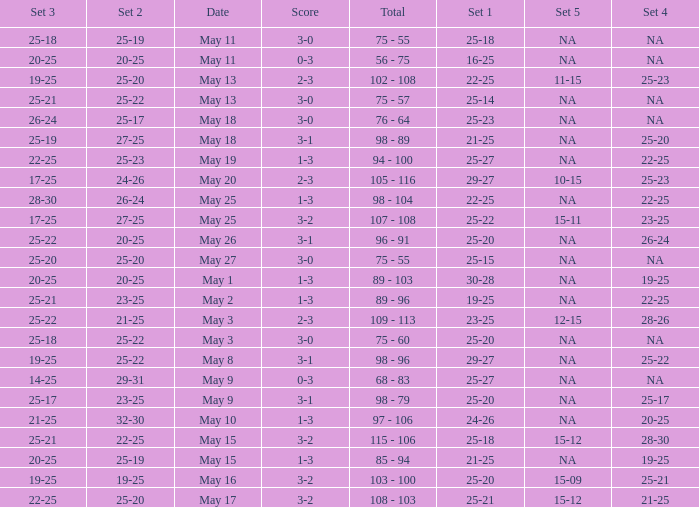Help me parse the entirety of this table. {'header': ['Set 3', 'Set 2', 'Date', 'Score', 'Total', 'Set 1', 'Set 5', 'Set 4'], 'rows': [['25-18', '25-19', 'May 11', '3-0', '75 - 55', '25-18', 'NA', 'NA'], ['20-25', '20-25', 'May 11', '0-3', '56 - 75', '16-25', 'NA', 'NA'], ['19-25', '25-20', 'May 13', '2-3', '102 - 108', '22-25', '11-15', '25-23'], ['25-21', '25-22', 'May 13', '3-0', '75 - 57', '25-14', 'NA', 'NA'], ['26-24', '25-17', 'May 18', '3-0', '76 - 64', '25-23', 'NA', 'NA'], ['25-19', '27-25', 'May 18', '3-1', '98 - 89', '21-25', 'NA', '25-20'], ['22-25', '25-23', 'May 19', '1-3', '94 - 100', '25-27', 'NA', '22-25'], ['17-25', '24-26', 'May 20', '2-3', '105 - 116', '29-27', '10-15', '25-23'], ['28-30', '26-24', 'May 25', '1-3', '98 - 104', '22-25', 'NA', '22-25'], ['17-25', '27-25', 'May 25', '3-2', '107 - 108', '25-22', '15-11', '23-25'], ['25-22', '20-25', 'May 26', '3-1', '96 - 91', '25-20', 'NA', '26-24'], ['25-20', '25-20', 'May 27', '3-0', '75 - 55', '25-15', 'NA', 'NA'], ['20-25', '20-25', 'May 1', '1-3', '89 - 103', '30-28', 'NA', '19-25'], ['25-21', '23-25', 'May 2', '1-3', '89 - 96', '19-25', 'NA', '22-25'], ['25-22', '21-25', 'May 3', '2-3', '109 - 113', '23-25', '12-15', '28-26'], ['25-18', '25-22', 'May 3', '3-0', '75 - 60', '25-20', 'NA', 'NA'], ['19-25', '25-22', 'May 8', '3-1', '98 - 96', '29-27', 'NA', '25-22'], ['14-25', '29-31', 'May 9', '0-3', '68 - 83', '25-27', 'NA', 'NA'], ['25-17', '23-25', 'May 9', '3-1', '98 - 79', '25-20', 'NA', '25-17'], ['21-25', '32-30', 'May 10', '1-3', '97 - 106', '24-26', 'NA', '20-25'], ['25-21', '22-25', 'May 15', '3-2', '115 - 106', '25-18', '15-12', '28-30'], ['20-25', '25-19', 'May 15', '1-3', '85 - 94', '21-25', 'NA', '19-25'], ['19-25', '19-25', 'May 16', '3-2', '103 - 100', '25-20', '15-09', '25-21'], ['22-25', '25-20', 'May 17', '3-2', '108 - 103', '25-21', '15-12', '21-25']]} What is the set 2 the has 1 set of 21-25, and 4 sets of 25-20? 27-25. 